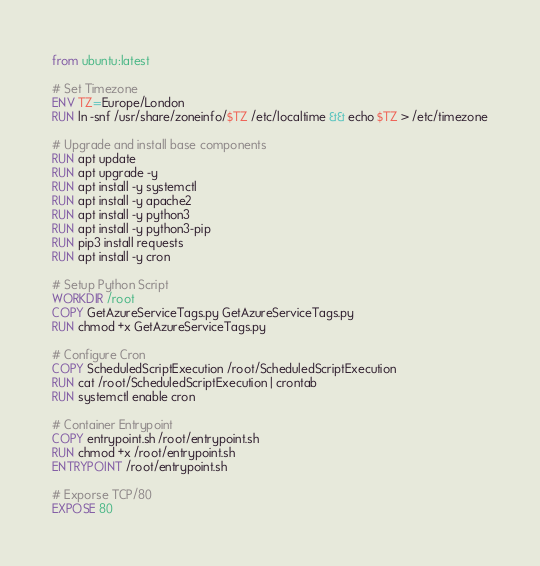Convert code to text. <code><loc_0><loc_0><loc_500><loc_500><_Dockerfile_>from ubuntu:latest

# Set Timezone
ENV TZ=Europe/London
RUN ln -snf /usr/share/zoneinfo/$TZ /etc/localtime && echo $TZ > /etc/timezone

# Upgrade and install base components
RUN apt update
RUN apt upgrade -y
RUN apt install -y systemctl
RUN apt install -y apache2
RUN apt install -y python3
RUN apt install -y python3-pip
RUN pip3 install requests
RUN apt install -y cron

# Setup Python Script
WORKDIR /root
COPY GetAzureServiceTags.py GetAzureServiceTags.py
RUN chmod +x GetAzureServiceTags.py

# Configure Cron
COPY ScheduledScriptExecution /root/ScheduledScriptExecution
RUN cat /root/ScheduledScriptExecution | crontab
RUN systemctl enable cron

# Container Entrypoint
COPY entrypoint.sh /root/entrypoint.sh
RUN chmod +x /root/entrypoint.sh
ENTRYPOINT /root/entrypoint.sh

# Exporse TCP/80
EXPOSE 80
</code> 